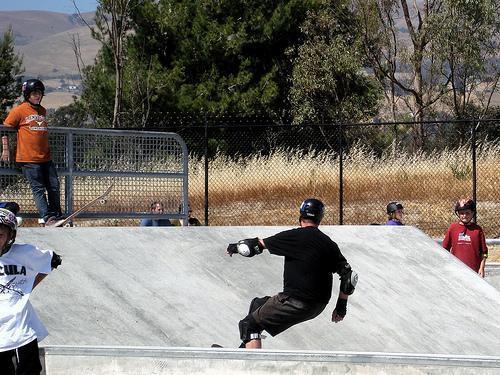How many people in all black?
Give a very brief answer. 1. How many people are in the picture?
Give a very brief answer. 7. 